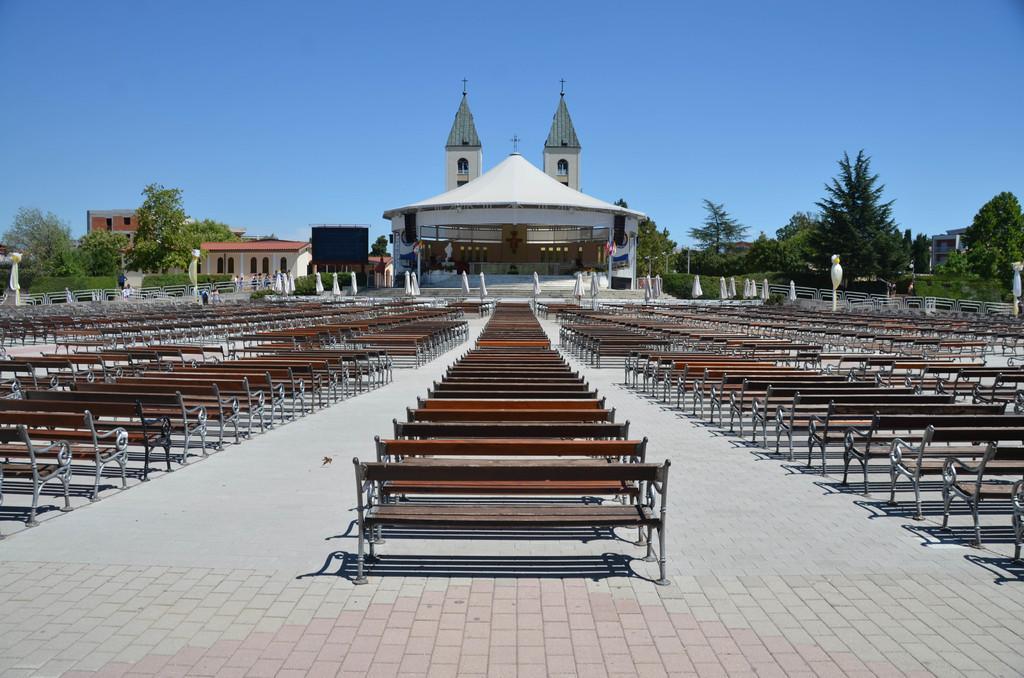Please provide a concise description of this image. In the image we can see there are many benches, this is a building, trees, fence, pole, windows of the buildings, floor and a pale blue sky. This is a cross symbol. 